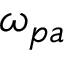Convert formula to latex. <formula><loc_0><loc_0><loc_500><loc_500>\omega _ { p a }</formula> 